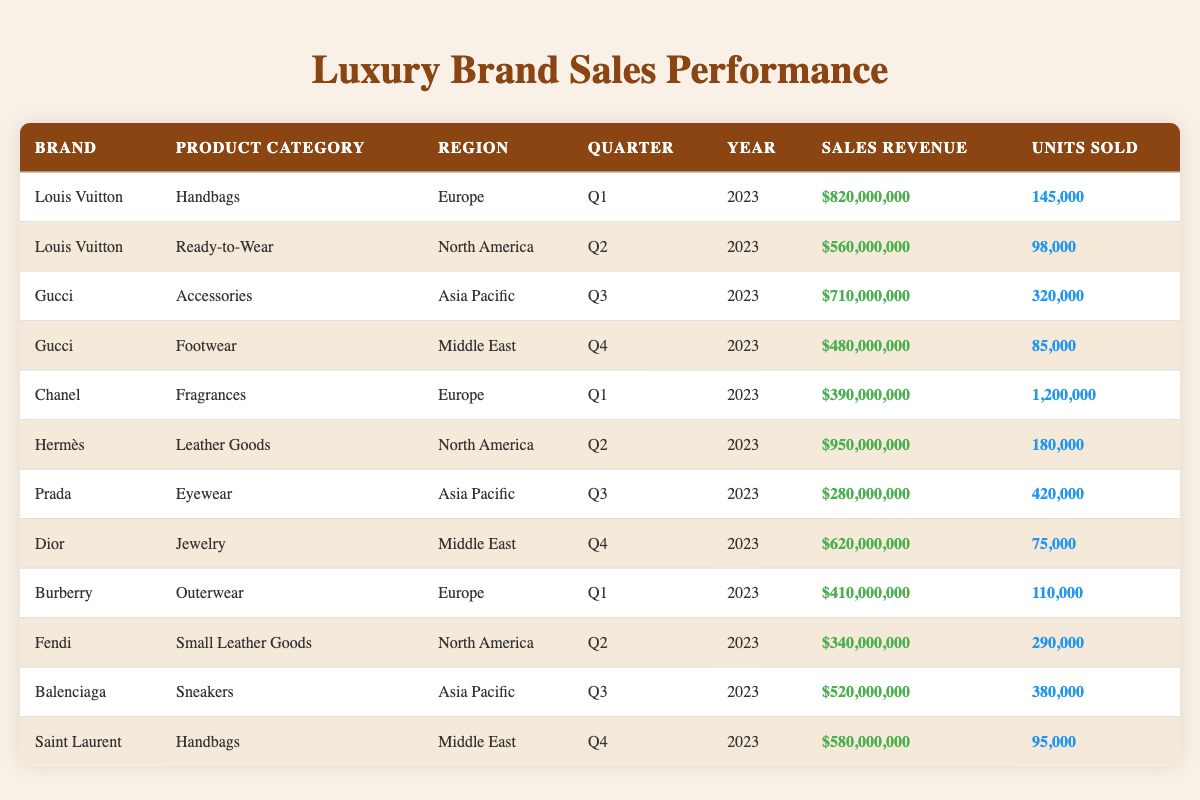What is the total sales revenue generated by Louis Vuitton in 2023? Louis Vuitton has sales revenue of $820,000,000 for Handbags in Q1 and $560,000,000 for Ready-to-Wear in Q2. Summing these, $820,000,000 + $560,000,000 equals $1,380,000,000.
Answer: $1,380,000,000 Which product category contributed the highest sales revenue in the Asia Pacific region? In the Asia Pacific region, Gucci's Accessories generated $710,000,000, Balenciaga's Sneakers generated $520,000,000, and Prada's Eyewear generated $280,000,000. Comparing these, $710,000,000 is the highest.
Answer: Accessories Did Chanel sell more units of Fragrances compared to Burberry's Outerwear? Chanel sold 1,200,000 units of Fragrances, while Burberry sold 110,000 units of Outerwear. Since 1,200,000 is greater than 110,000, the statement is true.
Answer: Yes What is the average sales revenue of the product categories sold in North America? The sales revenues for North America items are Hermès Leather Goods ($950,000,000) and Fendi Small Leather Goods ($340,000,000). The total revenue is $950,000,000 + $340,000,000 = $1,290,000,000. Since there are two product categories, the average is $1,290,000,000 / 2 = $645,000,000.
Answer: $645,000,000 How many units were sold in total for all product categories in Europe? In Europe, Louis Vuitton Handbags sold 145,000 units, Chanel Fragrances sold 1,200,000 units, and Burberry Outerwear sold 110,000 units. Summing these, 145,000 + 1,200,000 + 110,000 equals 1,455,000 units.
Answer: 1,455,000 units Which brand sold the lowest number of units in the Middle East? In the Middle East, Gucci sold 85,000 units of Footwear, and Dior sold 75,000 units of Jewelry. Comparing these, Dior sold the lowest number of units.
Answer: Dior Which brand has the highest sales revenue in Q1 2023? In Q1 2023, Louis Vuitton Handbags generated $820,000,000, Chanel Fragrances generated $390,000,000, and Burberry Outerwear generated $410,000,000. $820,000,000 from Louis Vuitton is the highest revenue in Q1.
Answer: Louis Vuitton What is the difference in units sold between the highest and lowest selling product categories in the Asia Pacific region? In the Asia Pacific region, Gucci's Accessories sold 320,000 units, while Prada's Eyewear sold 420,000 units. The difference in units sold is 420,000 - 280,000 = 100,000.
Answer: 100,000 units 